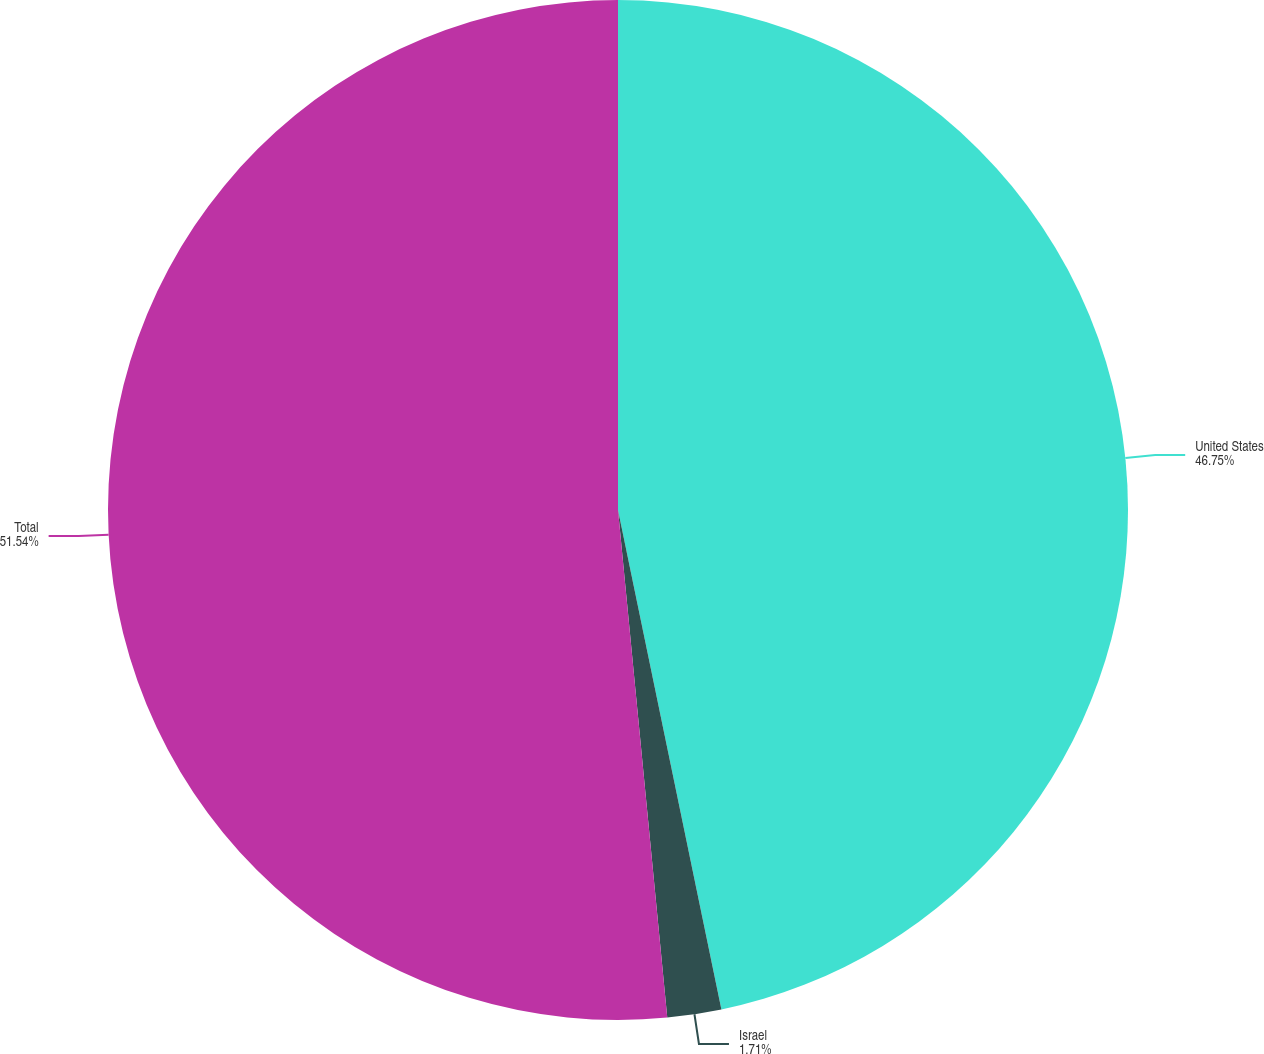Convert chart to OTSL. <chart><loc_0><loc_0><loc_500><loc_500><pie_chart><fcel>United States<fcel>Israel<fcel>Total<nl><fcel>46.75%<fcel>1.71%<fcel>51.54%<nl></chart> 